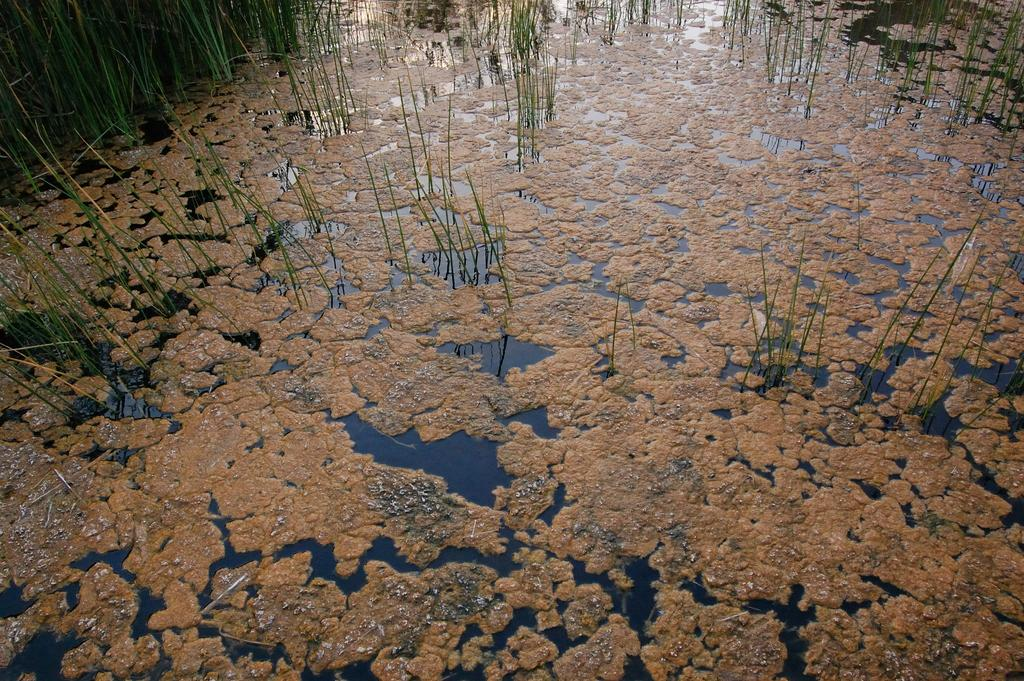What type of vegetation can be seen in the water? There is green grass in the water. What else can be observed floating on the water? There are algae floating on the water. Can you describe the beetle's journey across the water in the image? There is no beetle present in the image, so it is not possible to describe its journey across the water. 